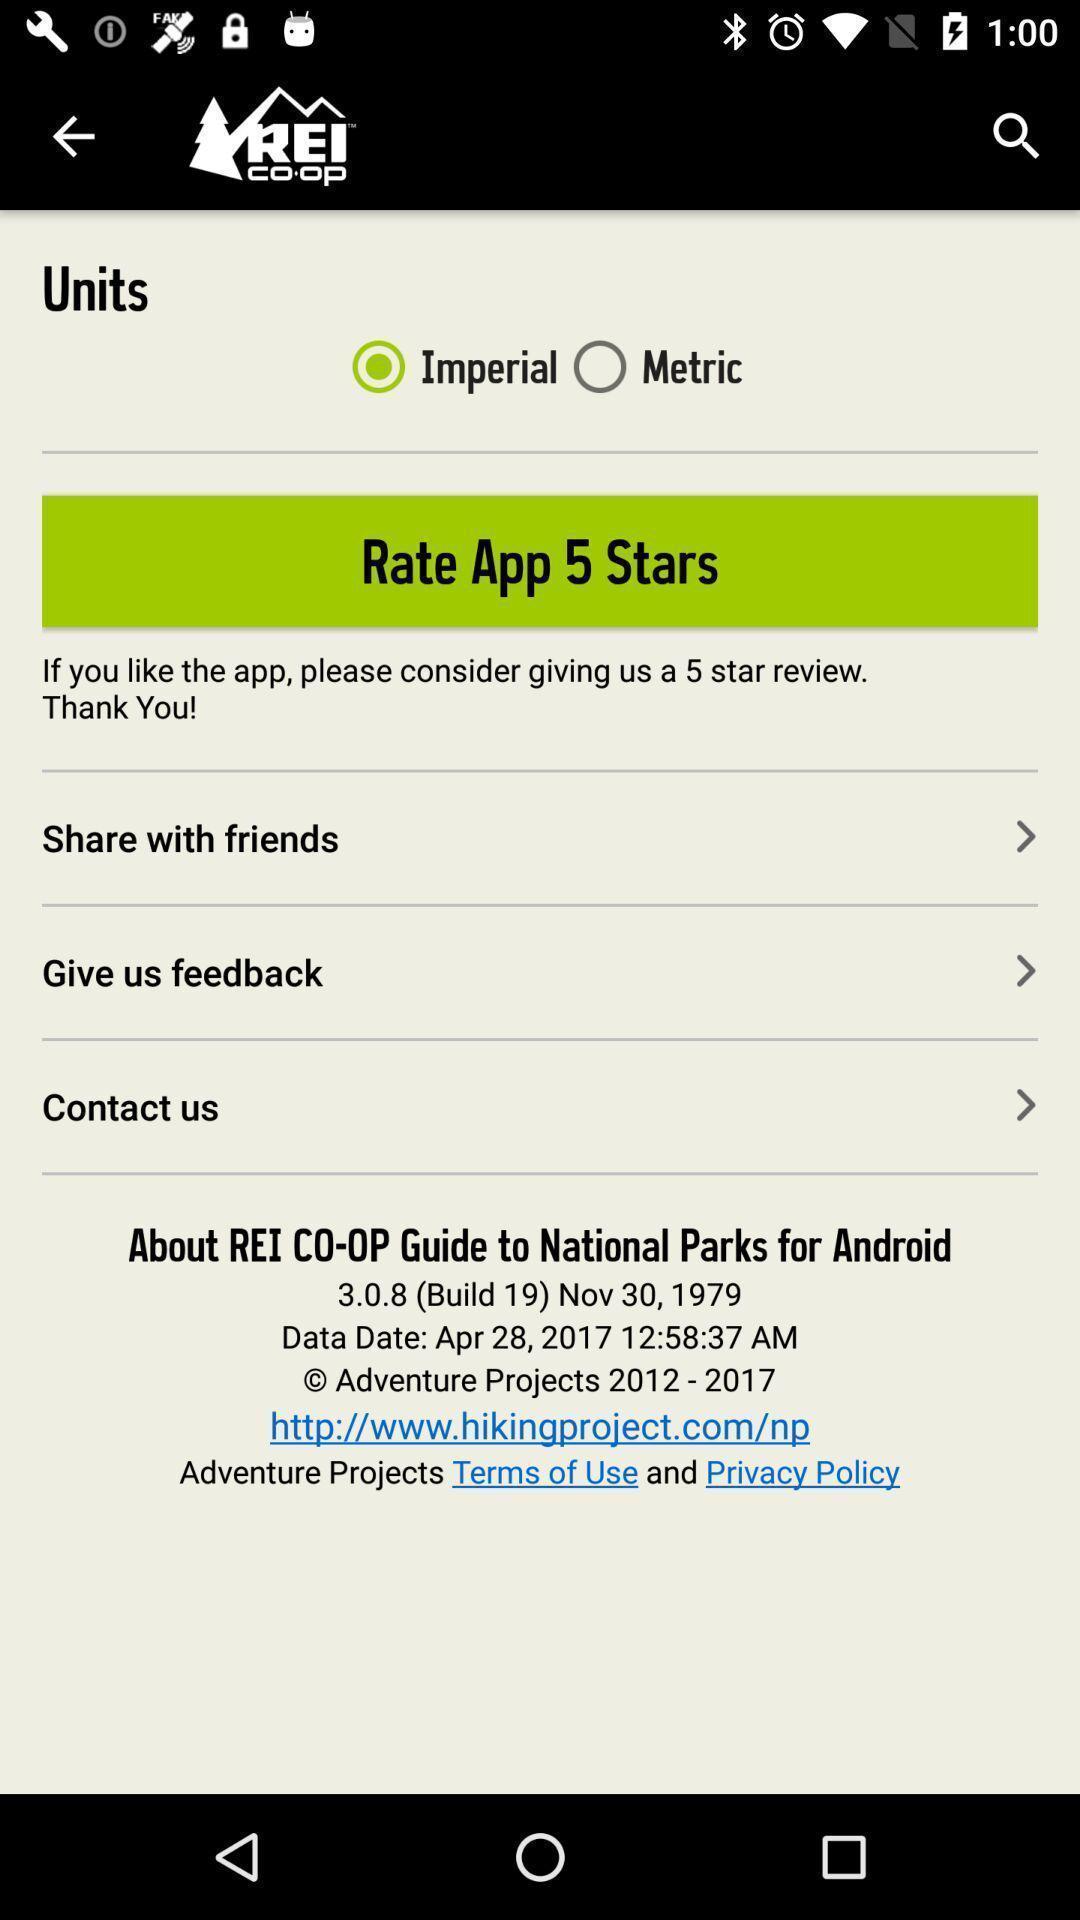Please provide a description for this image. Screen shows asking a feedback. 